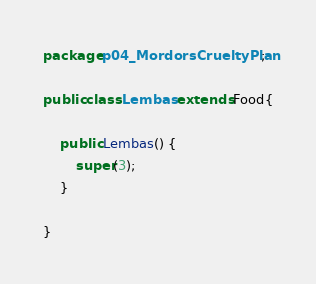Convert code to text. <code><loc_0><loc_0><loc_500><loc_500><_Java_>package p04_MordorsCrueltyPlan;

public class Lembas extends Food{

	public Lembas() {
		super(3);
	}
	
}
</code> 